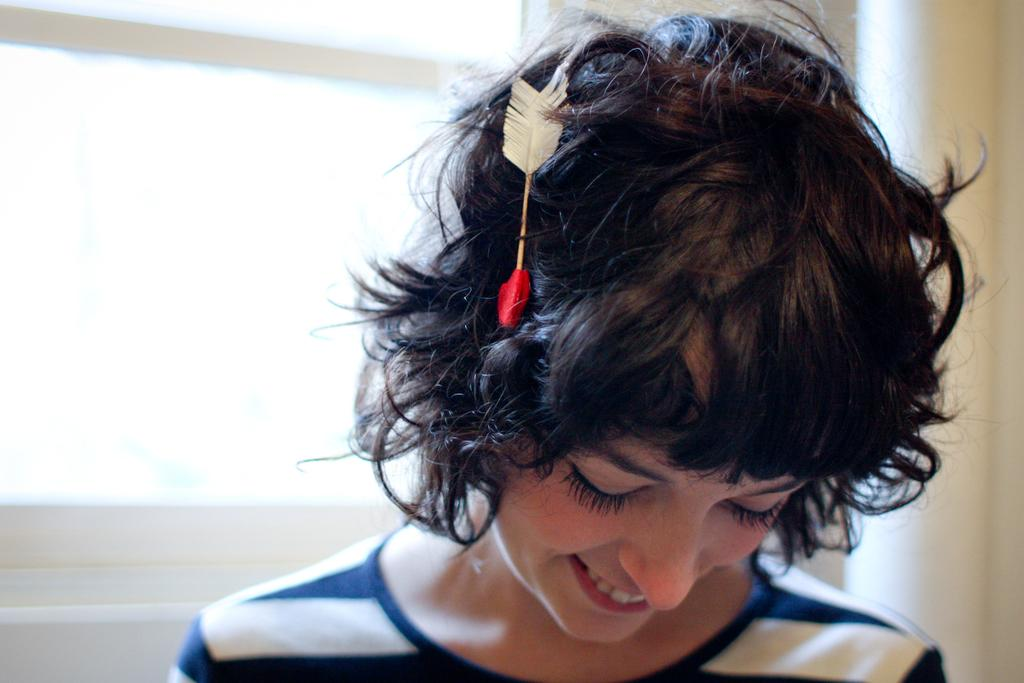Who is present in the image? There is a woman in the image. What expression does the woman have? The woman is smiling. What is on the woman's head? There is an object on the woman's head. What can be seen behind the woman? There is a wall behind the woman. What type of railway can be seen in the image? There is no railway present in the image. How does the sand affect the woman's appearance in the image? There is no sand present in the image, so it does not affect the woman's appearance. 